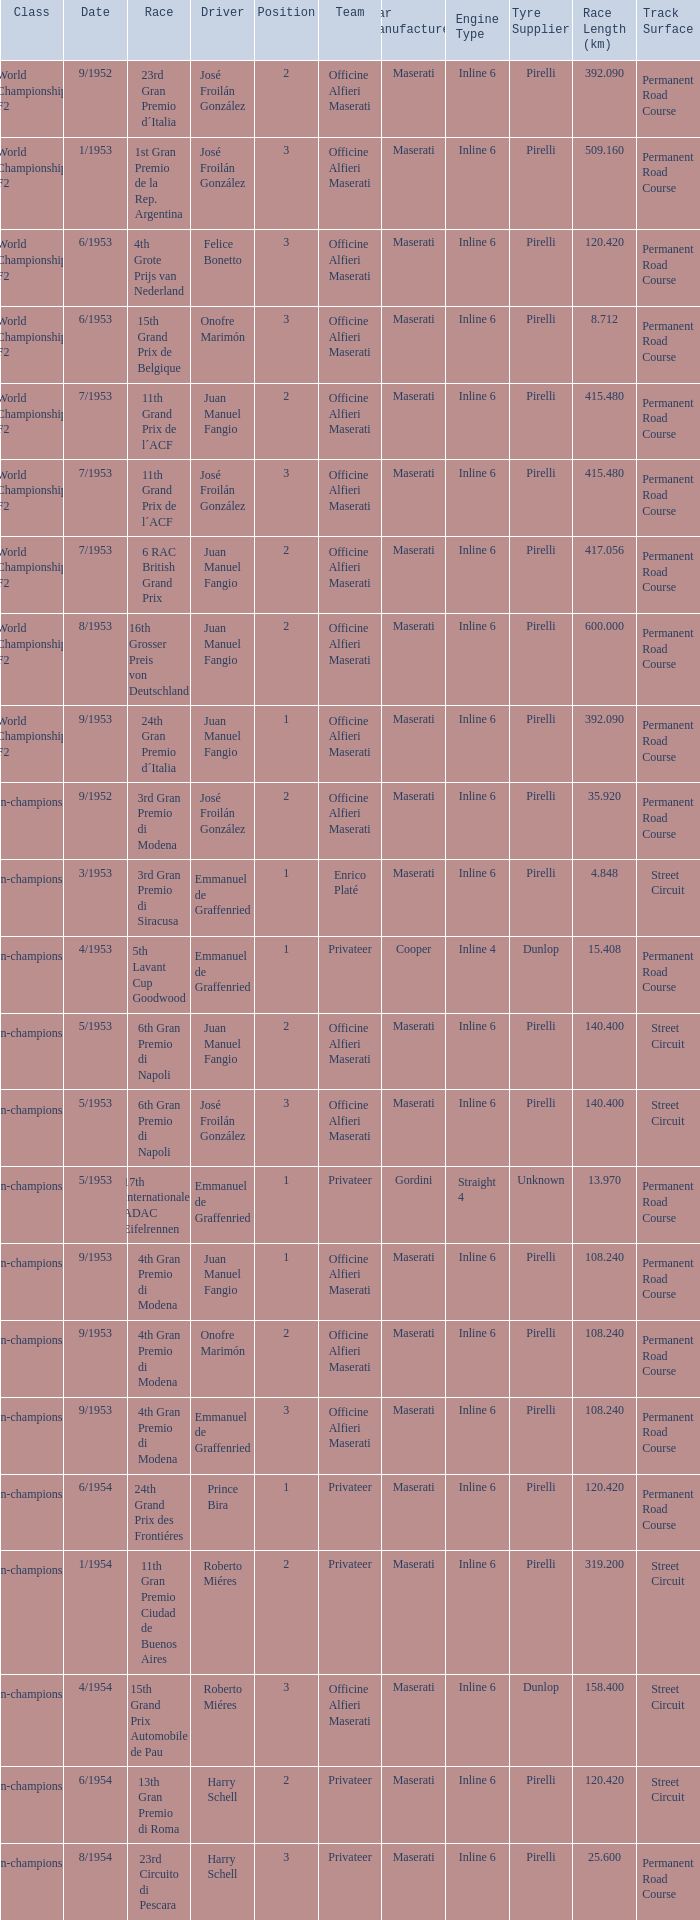What date has the class of non-championship f2 as well as a driver name josé froilán gonzález that has a position larger than 2? 5/1953. 